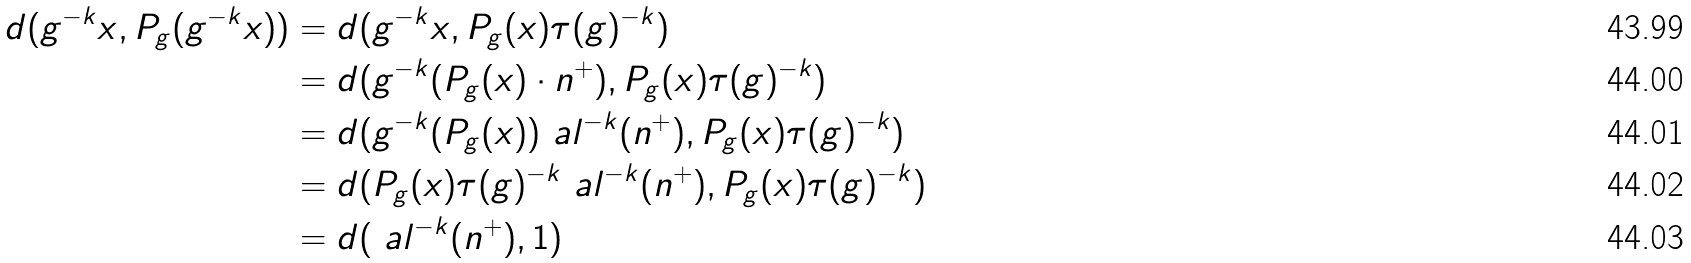Convert formula to latex. <formula><loc_0><loc_0><loc_500><loc_500>d ( g ^ { - k } x , P _ { g } ( g ^ { - k } x ) ) & = d ( g ^ { - k } x , P _ { g } ( x ) \tau ( g ) ^ { - k } ) \\ & = d ( g ^ { - k } ( P _ { g } ( x ) \cdot n ^ { + } ) , P _ { g } ( x ) \tau ( g ) ^ { - k } ) \\ & = d ( g ^ { - k } ( P _ { g } ( x ) ) \ a l ^ { - k } ( n ^ { + } ) , P _ { g } ( x ) \tau ( g ) ^ { - k } ) \\ & = d ( P _ { g } ( x ) \tau ( g ) ^ { - k } \ a l ^ { - k } ( n ^ { + } ) , P _ { g } ( x ) \tau ( g ) ^ { - k } ) \\ & = d ( \ a l ^ { - k } ( n ^ { + } ) , 1 )</formula> 